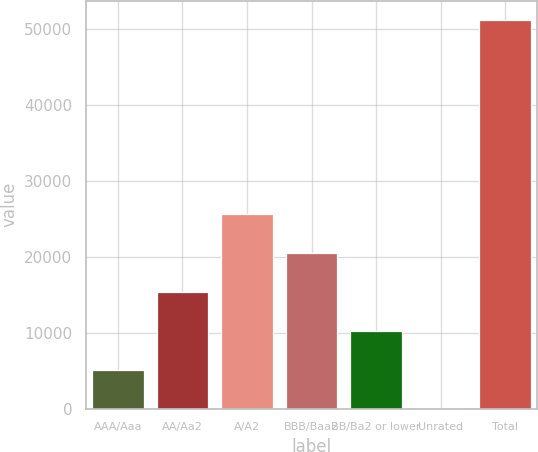Convert chart to OTSL. <chart><loc_0><loc_0><loc_500><loc_500><bar_chart><fcel>AAA/Aaa<fcel>AA/Aa2<fcel>A/A2<fcel>BBB/Baa2<fcel>BB/Ba2 or lower<fcel>Unrated<fcel>Total<nl><fcel>5152.8<fcel>15368.4<fcel>25666<fcel>20476.2<fcel>10260.6<fcel>45<fcel>51123<nl></chart> 